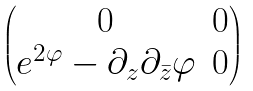Convert formula to latex. <formula><loc_0><loc_0><loc_500><loc_500>\begin{pmatrix} 0 & 0 \\ e ^ { 2 \varphi } - \partial _ { z } \partial _ { \bar { z } } \varphi & 0 \end{pmatrix}</formula> 